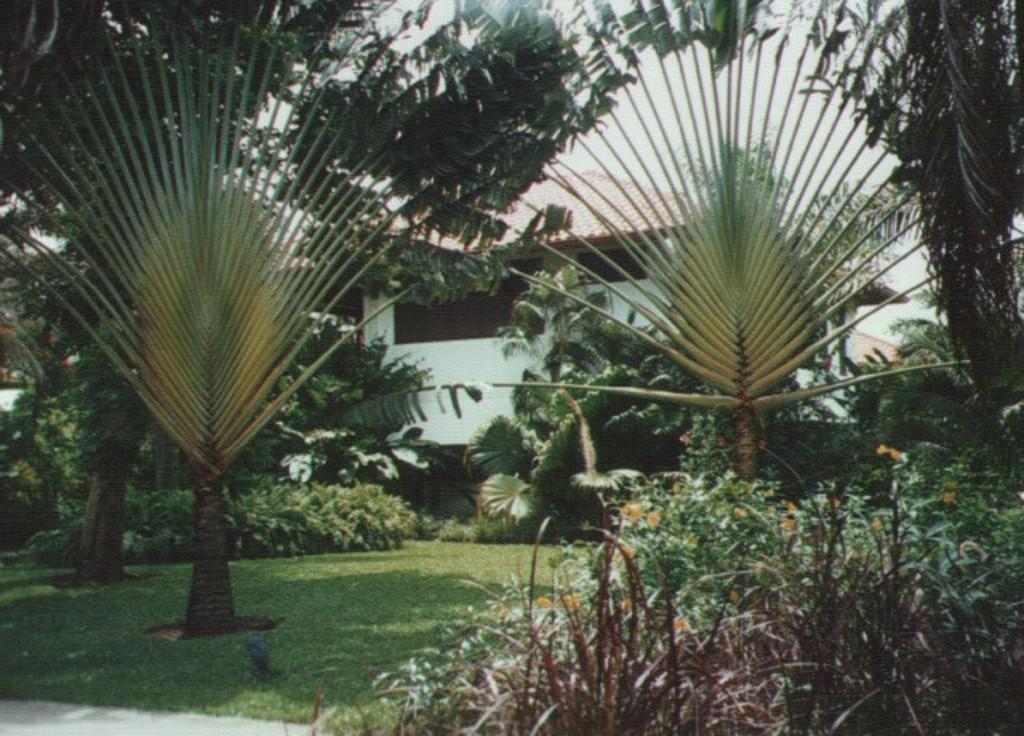How would you summarize this image in a sentence or two? In this image we can see trees, grass, plants and building. In the background there is sky. 